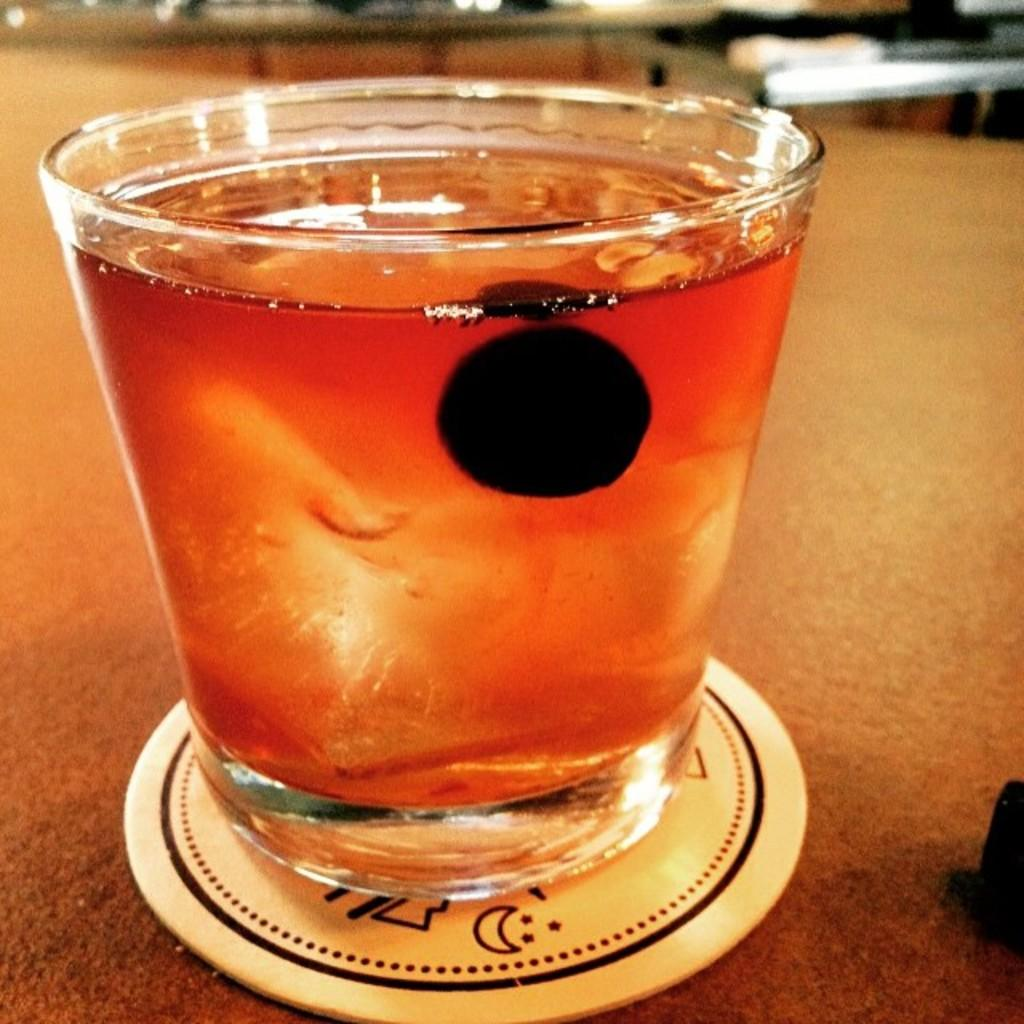What is in the glass that is visible in the image? There is a drink in the glass. What type of dress is the glass wearing in the image? There is no dress present in the image, as the subject is a glass with a drink in it. 